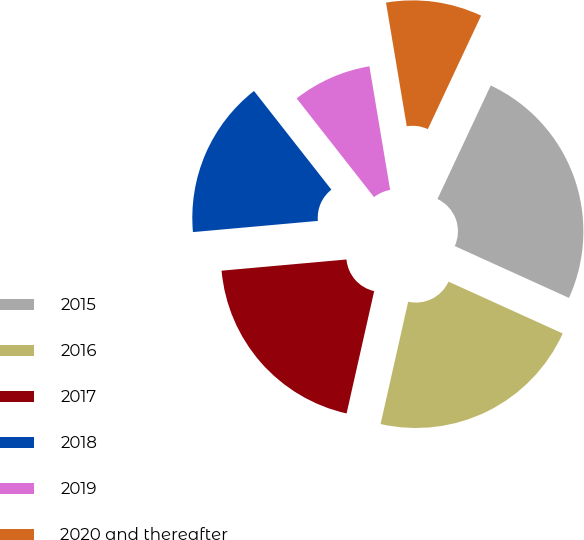Convert chart. <chart><loc_0><loc_0><loc_500><loc_500><pie_chart><fcel>2015<fcel>2016<fcel>2017<fcel>2018<fcel>2019<fcel>2020 and thereafter<nl><fcel>24.8%<fcel>21.75%<fcel>20.05%<fcel>15.84%<fcel>7.94%<fcel>9.63%<nl></chart> 